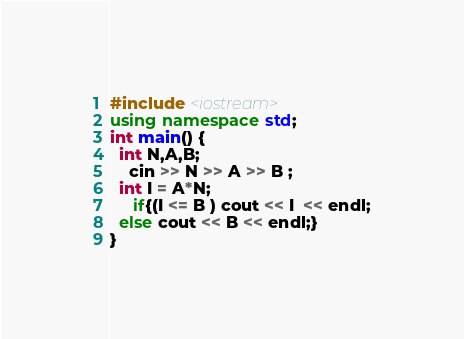<code> <loc_0><loc_0><loc_500><loc_500><_C++_>#include <iostream>
using namespace std;
int main() {
  int N,A,B;
	cin >> N >> A >> B ;
  int I = A*N;
	 if{(I <= B ) cout << I  << endl;
  else cout << B << endl;}
}
</code> 